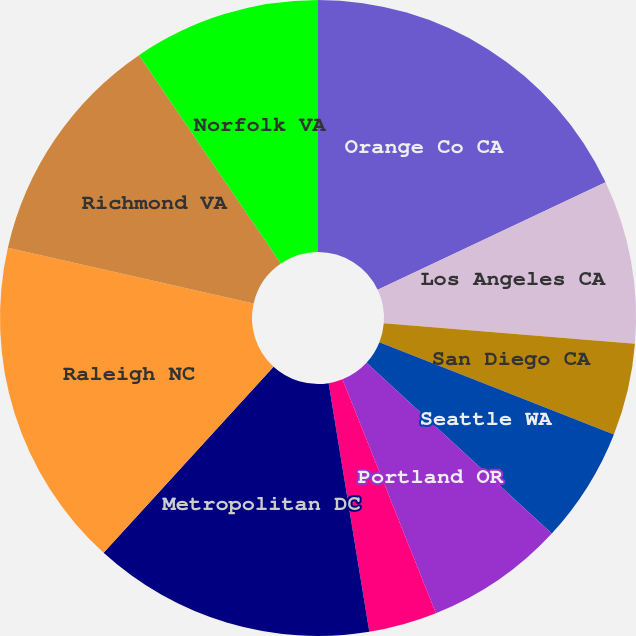Convert chart. <chart><loc_0><loc_0><loc_500><loc_500><pie_chart><fcel>Orange Co CA<fcel>Los Angeles CA<fcel>San Diego CA<fcel>Seattle WA<fcel>Portland OR<fcel>Sacramento CA<fcel>Metropolitan DC<fcel>Raleigh NC<fcel>Richmond VA<fcel>Norfolk VA<nl><fcel>17.99%<fcel>8.31%<fcel>4.68%<fcel>5.89%<fcel>7.1%<fcel>3.47%<fcel>14.36%<fcel>16.78%<fcel>11.94%<fcel>9.52%<nl></chart> 